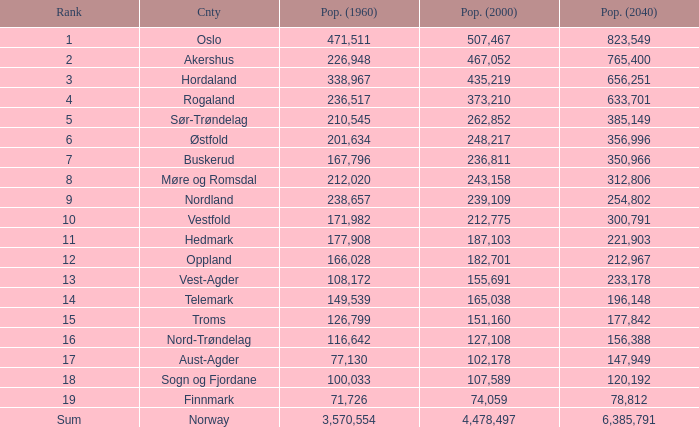What was the population of a county in 1960 that had a population of 467,052 in 2000 and 78,812 in 2040? None. 